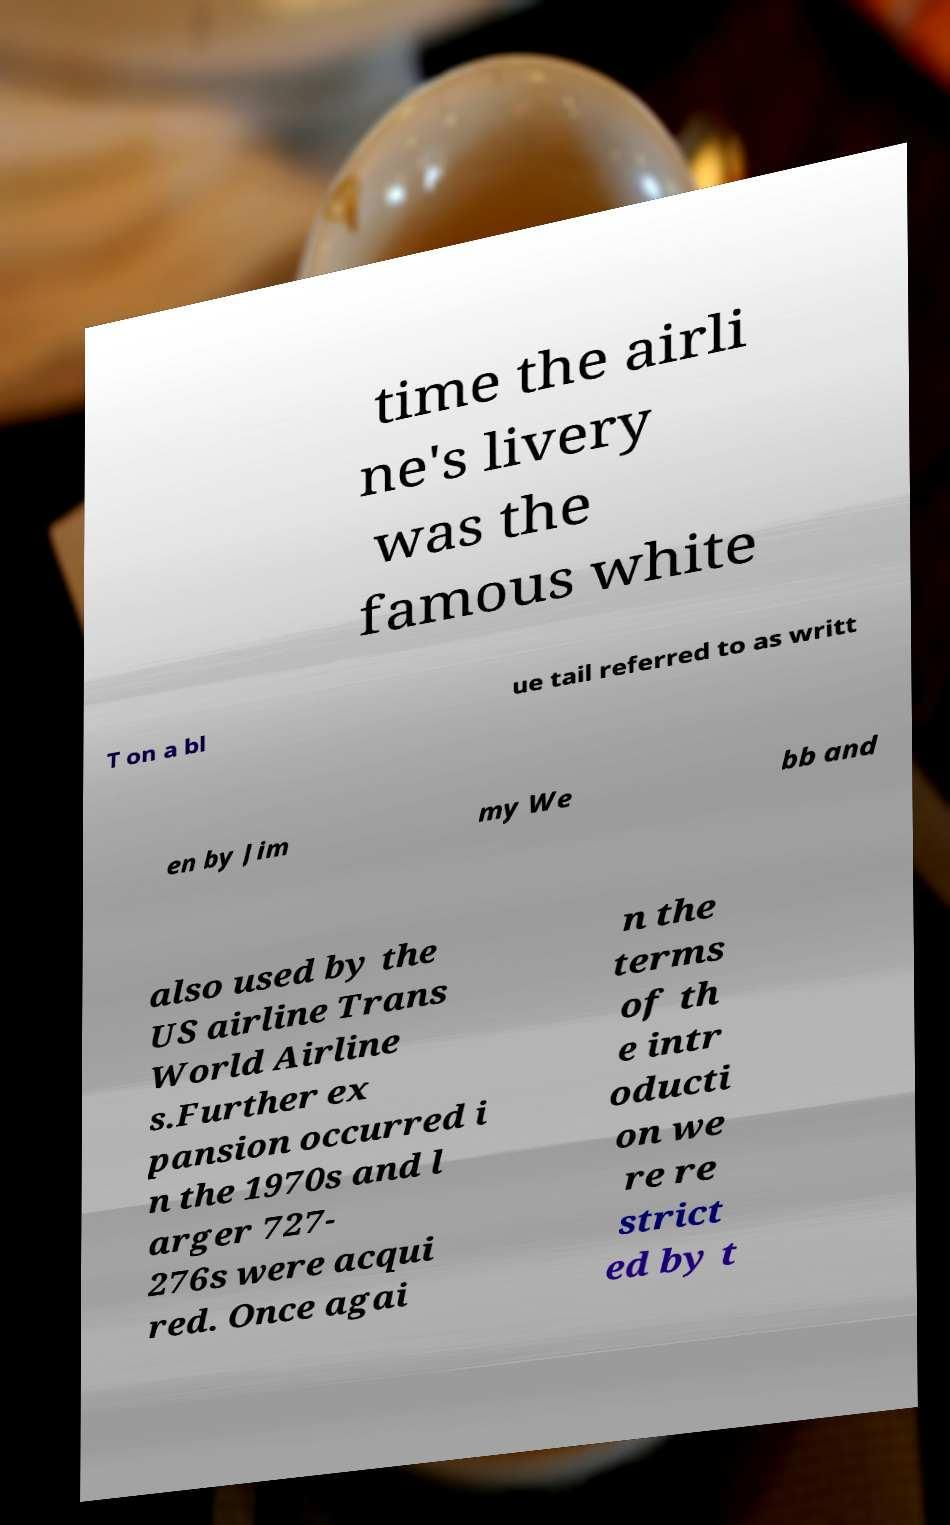Please read and relay the text visible in this image. What does it say? time the airli ne's livery was the famous white T on a bl ue tail referred to as writt en by Jim my We bb and also used by the US airline Trans World Airline s.Further ex pansion occurred i n the 1970s and l arger 727- 276s were acqui red. Once agai n the terms of th e intr oducti on we re re strict ed by t 